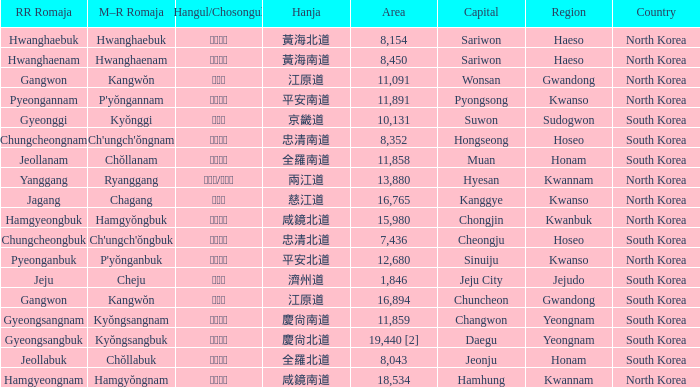Which capital has a Hangul of 경상남도? Changwon. 